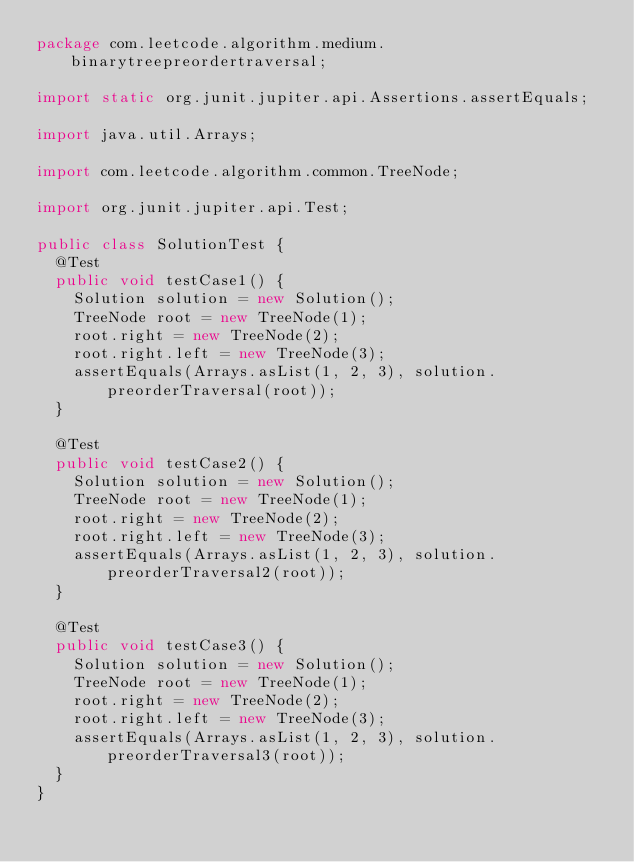<code> <loc_0><loc_0><loc_500><loc_500><_Java_>package com.leetcode.algorithm.medium.binarytreepreordertraversal;

import static org.junit.jupiter.api.Assertions.assertEquals;

import java.util.Arrays;

import com.leetcode.algorithm.common.TreeNode;

import org.junit.jupiter.api.Test;

public class SolutionTest {
  @Test
  public void testCase1() {
    Solution solution = new Solution();
    TreeNode root = new TreeNode(1);
    root.right = new TreeNode(2);
    root.right.left = new TreeNode(3);
    assertEquals(Arrays.asList(1, 2, 3), solution.preorderTraversal(root));
  }

  @Test
  public void testCase2() {
    Solution solution = new Solution();
    TreeNode root = new TreeNode(1);
    root.right = new TreeNode(2);
    root.right.left = new TreeNode(3);
    assertEquals(Arrays.asList(1, 2, 3), solution.preorderTraversal2(root));
  }

  @Test
  public void testCase3() {
    Solution solution = new Solution();
    TreeNode root = new TreeNode(1);
    root.right = new TreeNode(2);
    root.right.left = new TreeNode(3);
    assertEquals(Arrays.asList(1, 2, 3), solution.preorderTraversal3(root));
  }
}
</code> 